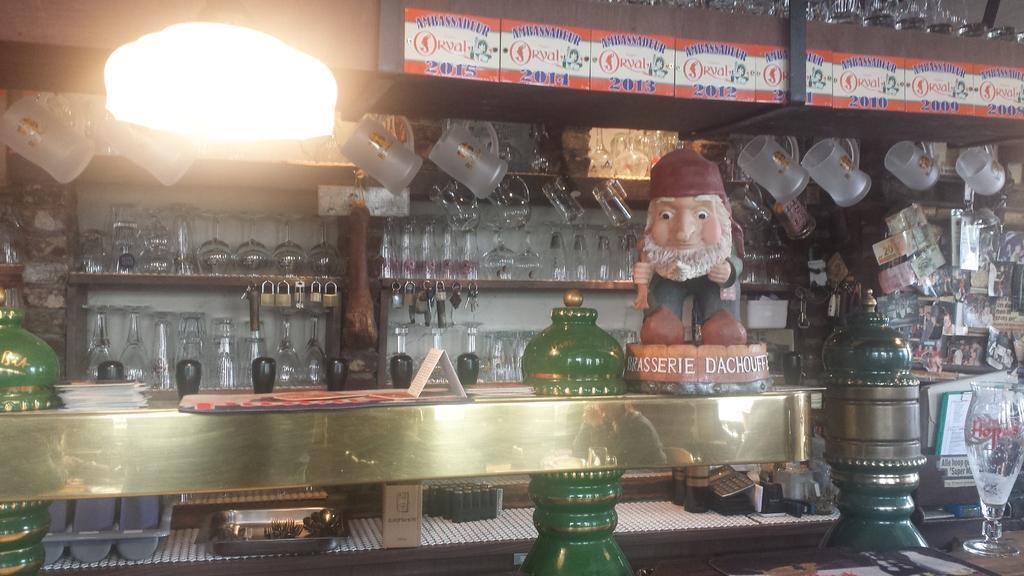Can you describe this image briefly? In this picture we can see a few glasses in the shelves. There are jugs on top. We can see a card,toy and papers on a desk. We can see some green objects. There are few objects on the right side. A light is visible on the left side. 